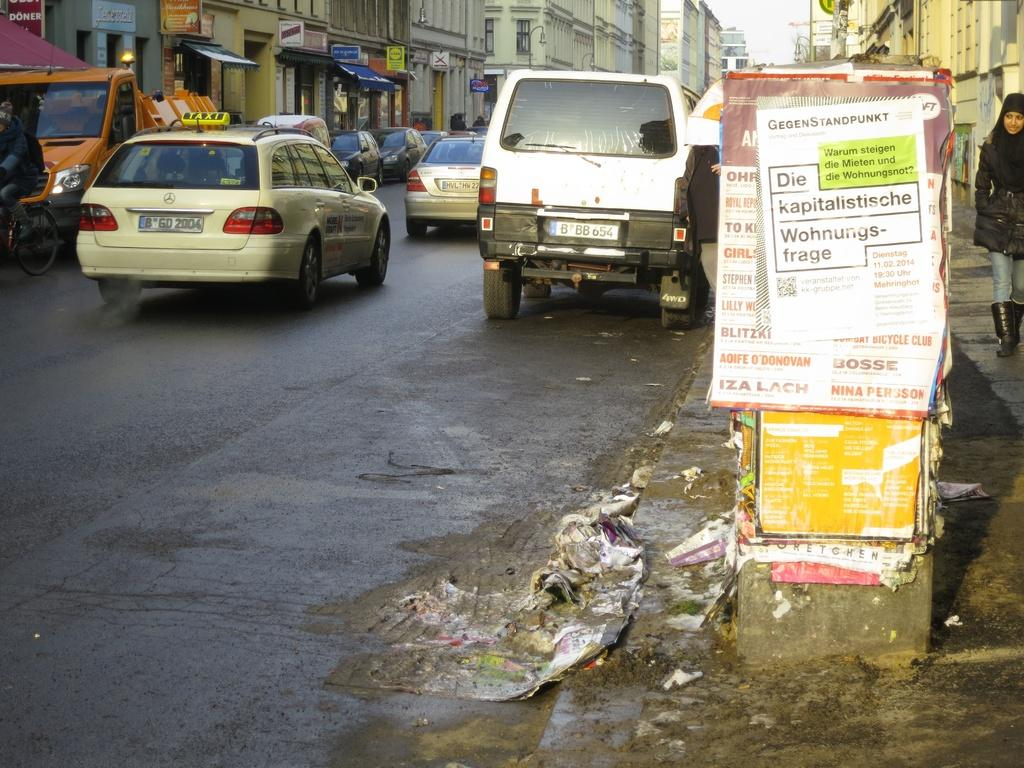<image>
Present a compact description of the photo's key features. A sign that starts with the word GegenStandpunkt is posted on a pillar over a dirty sidewalk. 